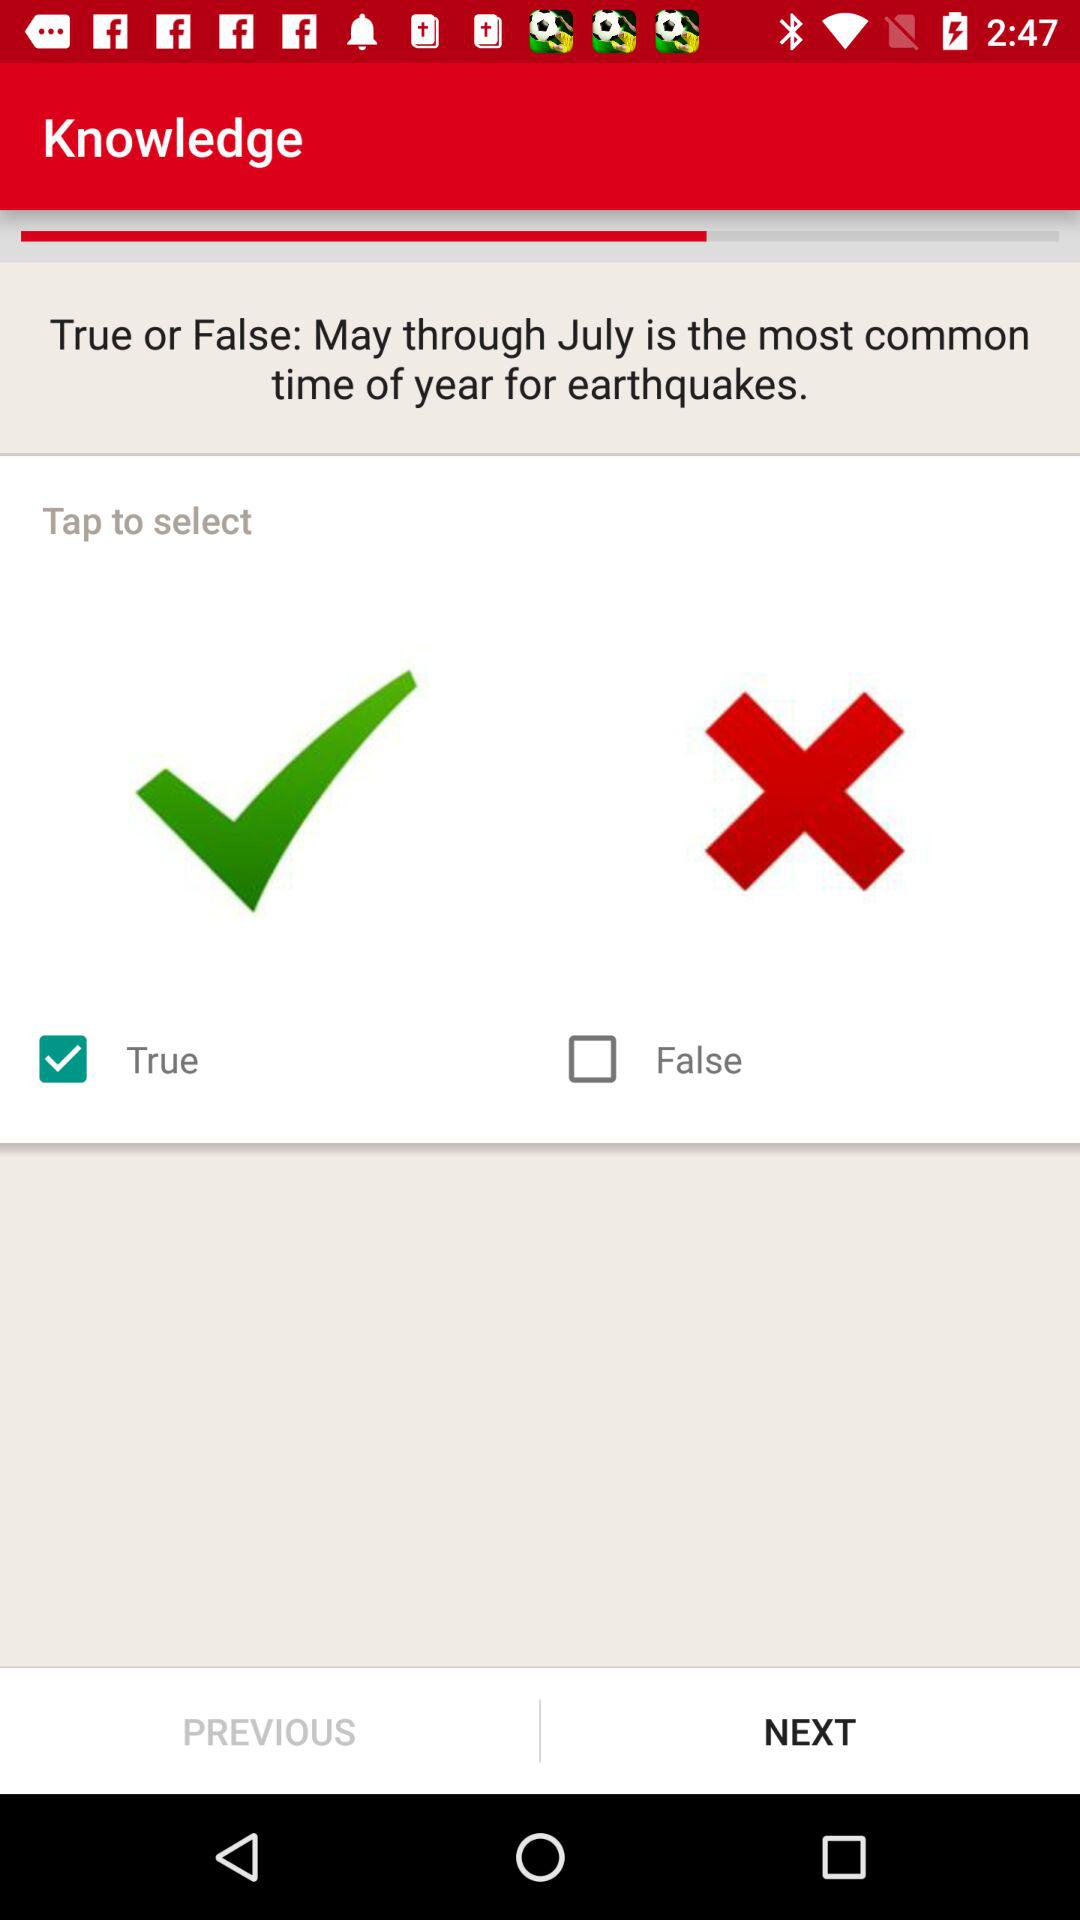What option is marked as checked? The option is "True". 